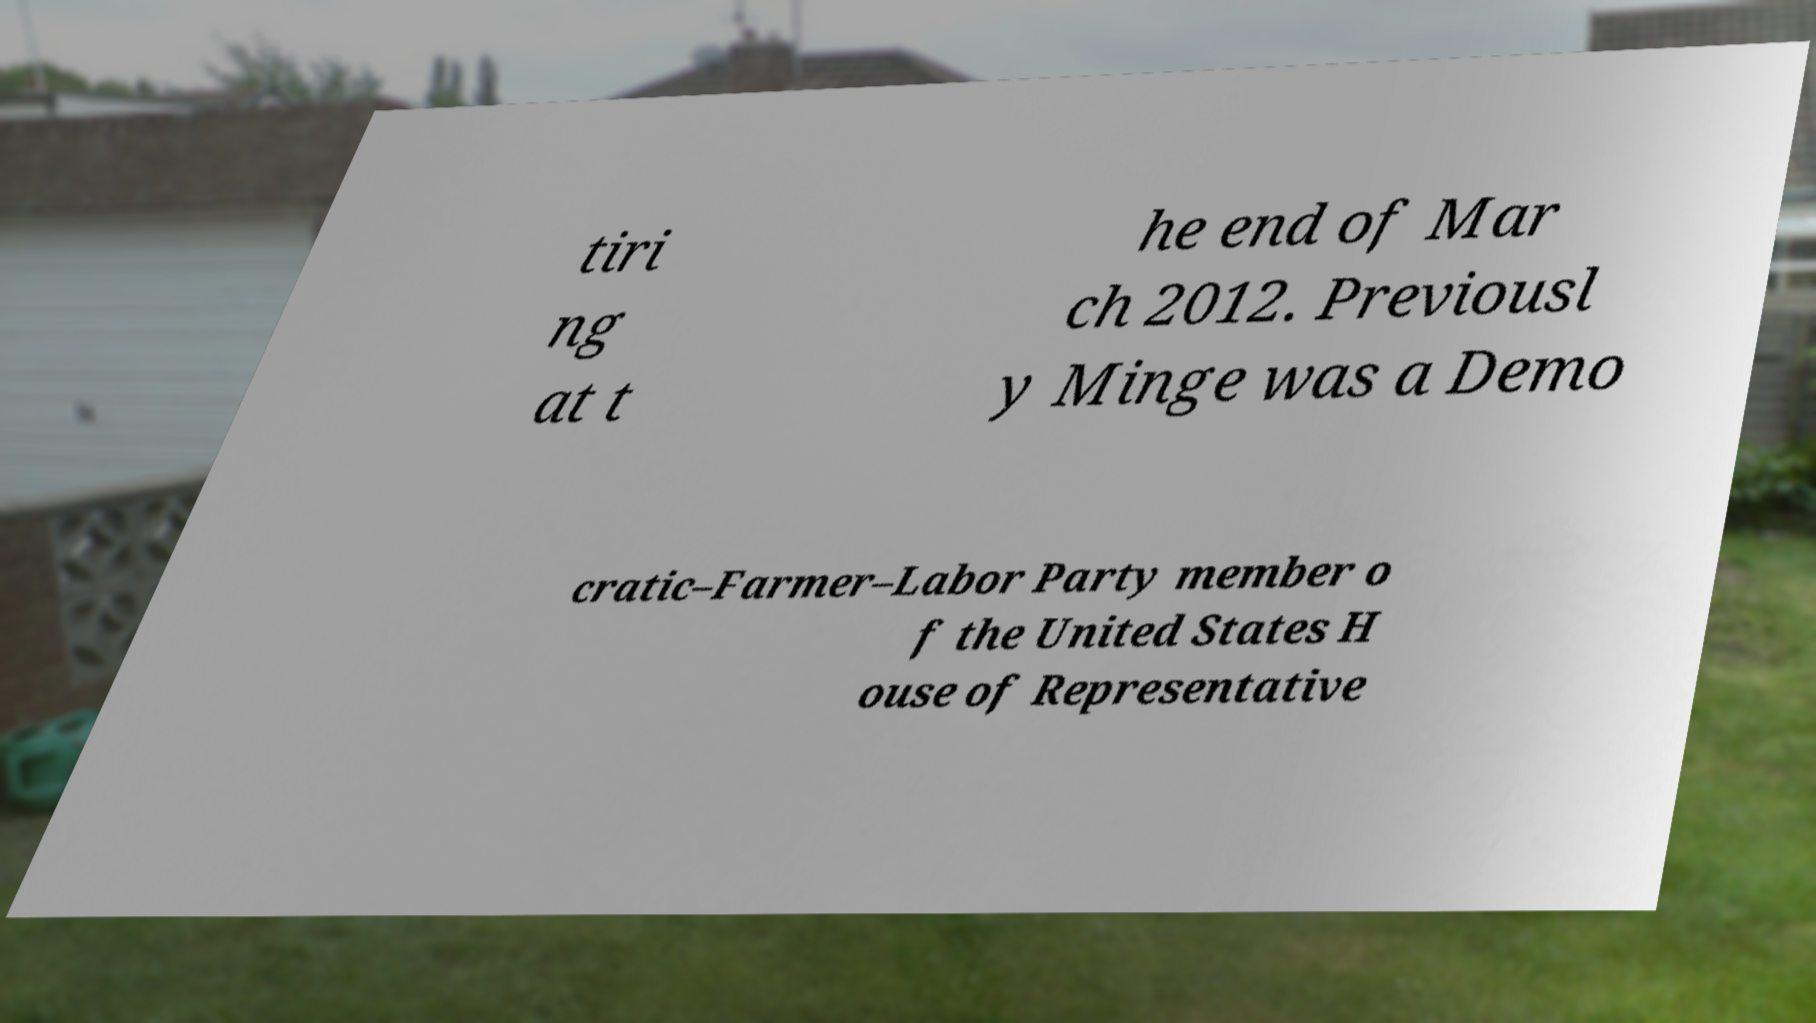Could you extract and type out the text from this image? tiri ng at t he end of Mar ch 2012. Previousl y Minge was a Demo cratic–Farmer–Labor Party member o f the United States H ouse of Representative 